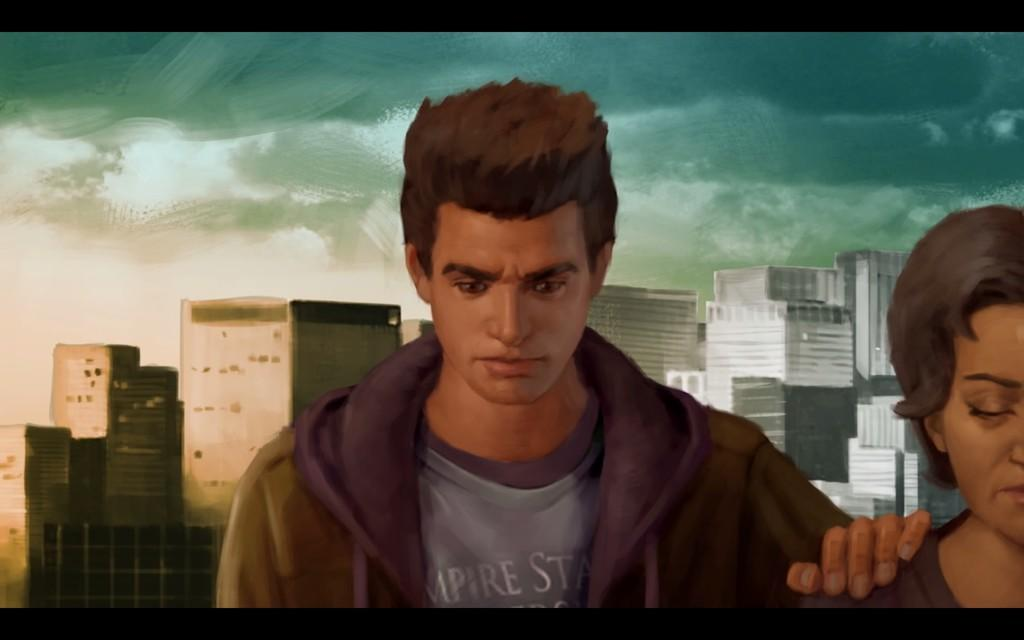What are the main subjects depicted in the image? There is a depiction of a man and a woman in the image. What can be seen in the background of the image? There are depictions of buildings in the background of the image. What type of bone is being used by the man in the image? There is no bone present in the image; it features depictions of a man and a woman, along with buildings in the background. 